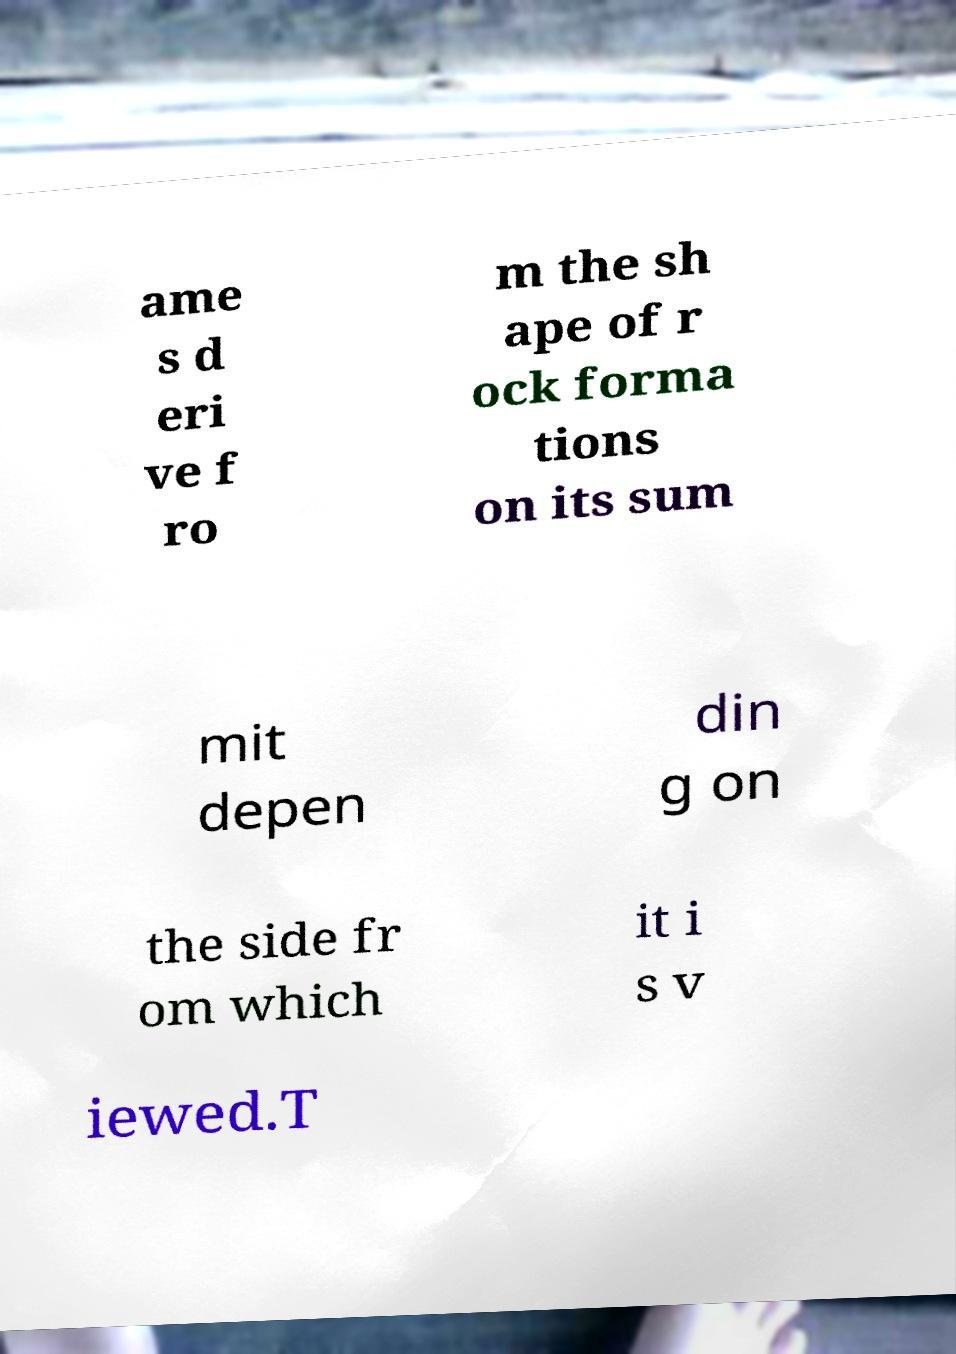Please read and relay the text visible in this image. What does it say? ame s d eri ve f ro m the sh ape of r ock forma tions on its sum mit depen din g on the side fr om which it i s v iewed.T 